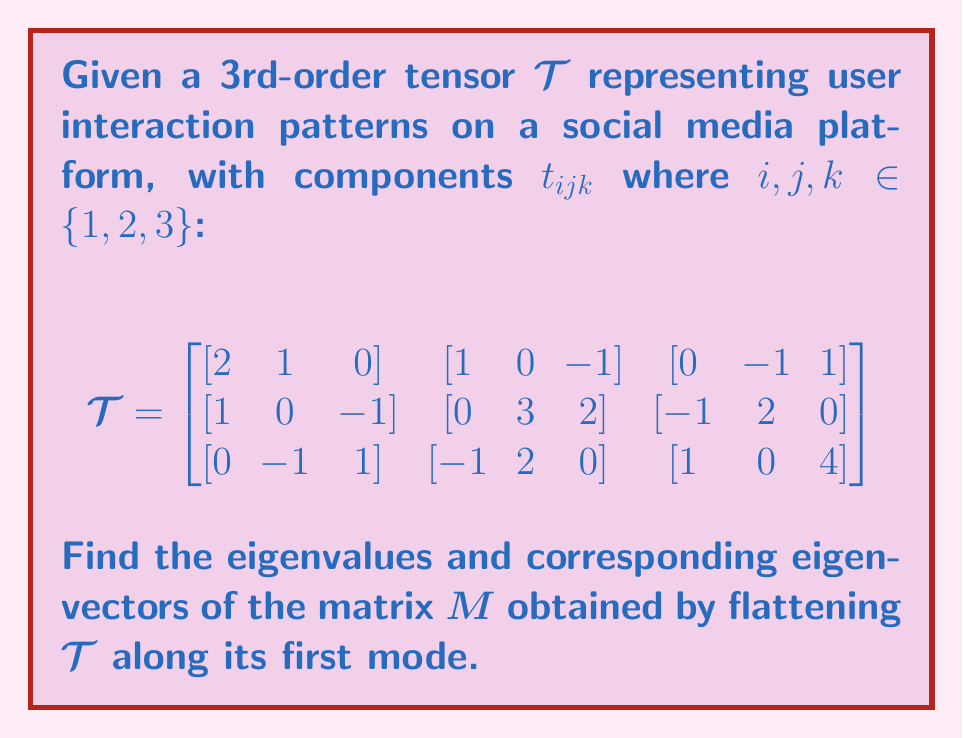Can you answer this question? 1) First, we need to flatten the tensor $\mathcal{T}$ along its first mode to obtain matrix $M$. This results in a $3 \times 9$ matrix:

$$M = \begin{bmatrix}
2 & 1 & 0 & 1 & 0 & -1 & 0 & -1 & 1 \\
1 & 0 & -1 & 0 & 3 & 2 & -1 & 2 & 0 \\
0 & -1 & 1 & -1 & 2 & 0 & 1 & 0 & 4
\end{bmatrix}$$

2) To find the eigenvalues and eigenvectors, we need to compute $MM^T$:

$$MM^T = \begin{bmatrix}
8 & 2 & -1 \\
2 & 15 & 1 \\
-1 & 1 & 23
\end{bmatrix}$$

3) Now, we solve the characteristic equation $\det(MM^T - \lambda I) = 0$:

$$\det\begin{bmatrix}
8-\lambda & 2 & -1 \\
2 & 15-\lambda & 1 \\
-1 & 1 & 23-\lambda
\end{bmatrix} = 0$$

4) Expanding this determinant:

$$(8-\lambda)((15-\lambda)(23-\lambda)-1) - 2(2(23-\lambda)+1) + (-1)(-2+15-\lambda) = 0$$

$$(8-\lambda)(345-38\lambda+\lambda^2-1) - 2(46-2\lambda+1) + (13-\lambda) = 0$$

$$2760-304\lambda+8\lambda^2-8+\lambda-38\lambda+\lambda^3 - 94+4\lambda-2+13-\lambda = 0$$

$$\lambda^3 - 33\lambda^2 - 337\lambda + 2669 = 0$$

5) Solving this cubic equation (using a computer algebra system), we get the eigenvalues:

$\lambda_1 \approx 23.9739$, $\lambda_2 \approx 15.0130$, $\lambda_3 \approx 7.0131$

6) For each eigenvalue $\lambda_i$, we solve $(MM^T - \lambda_i I)v = 0$ to find the corresponding eigenvector $v$:

For $\lambda_1 \approx 23.9739$:
$$v_1 \approx [-0.0435, 0.0435, 0.9981]^T$$

For $\lambda_2 \approx 15.0130$:
$$v_2 \approx [-0.1305, 0.9829, -0.1305]^T$$

For $\lambda_3 \approx 7.0131$:
$$v_3 \approx [0.9905, 0.1370, -0.0087]^T$$
Answer: Eigenvalues: $\lambda_1 \approx 23.9739$, $\lambda_2 \approx 15.0130$, $\lambda_3 \approx 7.0131$
Eigenvectors: $v_1 \approx [-0.0435, 0.0435, 0.9981]^T$, $v_2 \approx [-0.1305, 0.9829, -0.1305]^T$, $v_3 \approx [0.9905, 0.1370, -0.0087]^T$ 